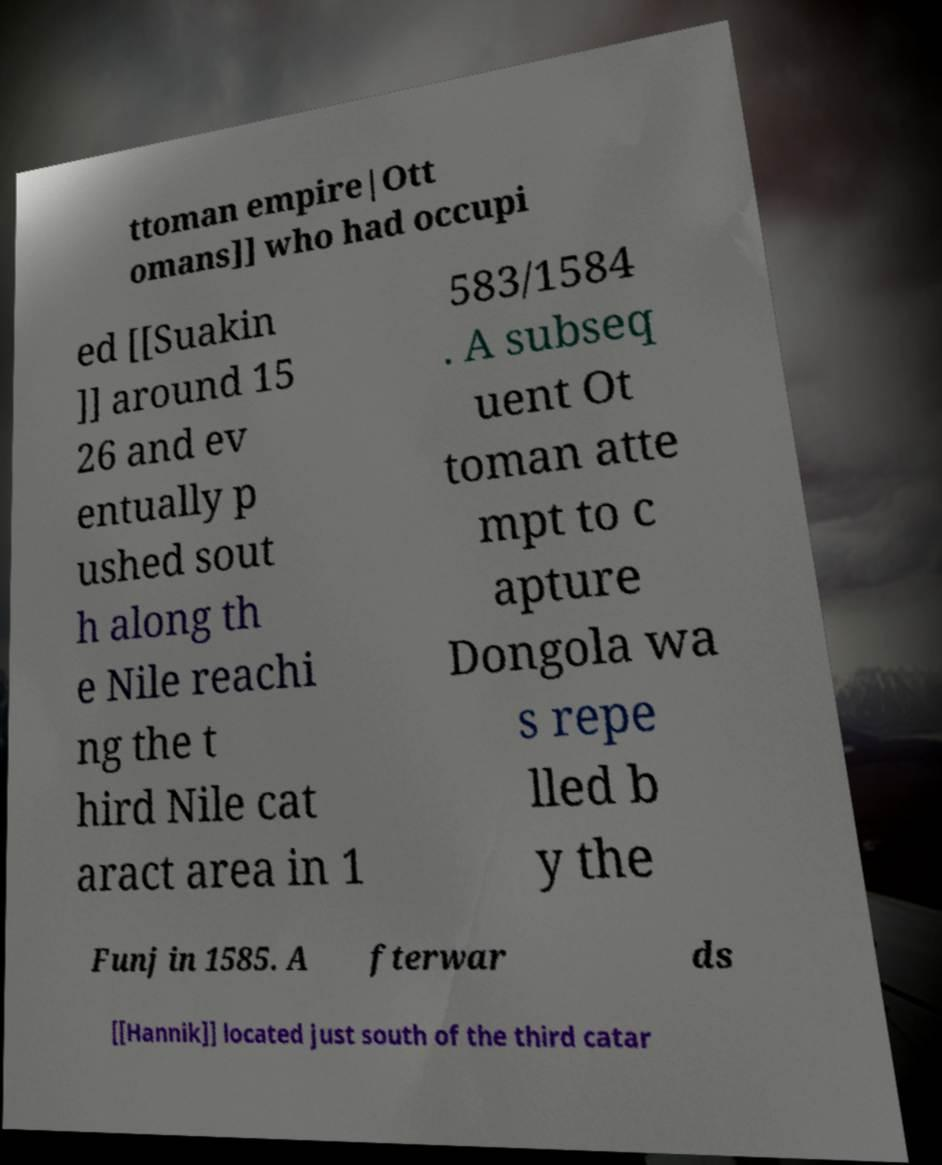Could you assist in decoding the text presented in this image and type it out clearly? ttoman empire|Ott omans]] who had occupi ed [[Suakin ]] around 15 26 and ev entually p ushed sout h along th e Nile reachi ng the t hird Nile cat aract area in 1 583/1584 . A subseq uent Ot toman atte mpt to c apture Dongola wa s repe lled b y the Funj in 1585. A fterwar ds [[Hannik]] located just south of the third catar 